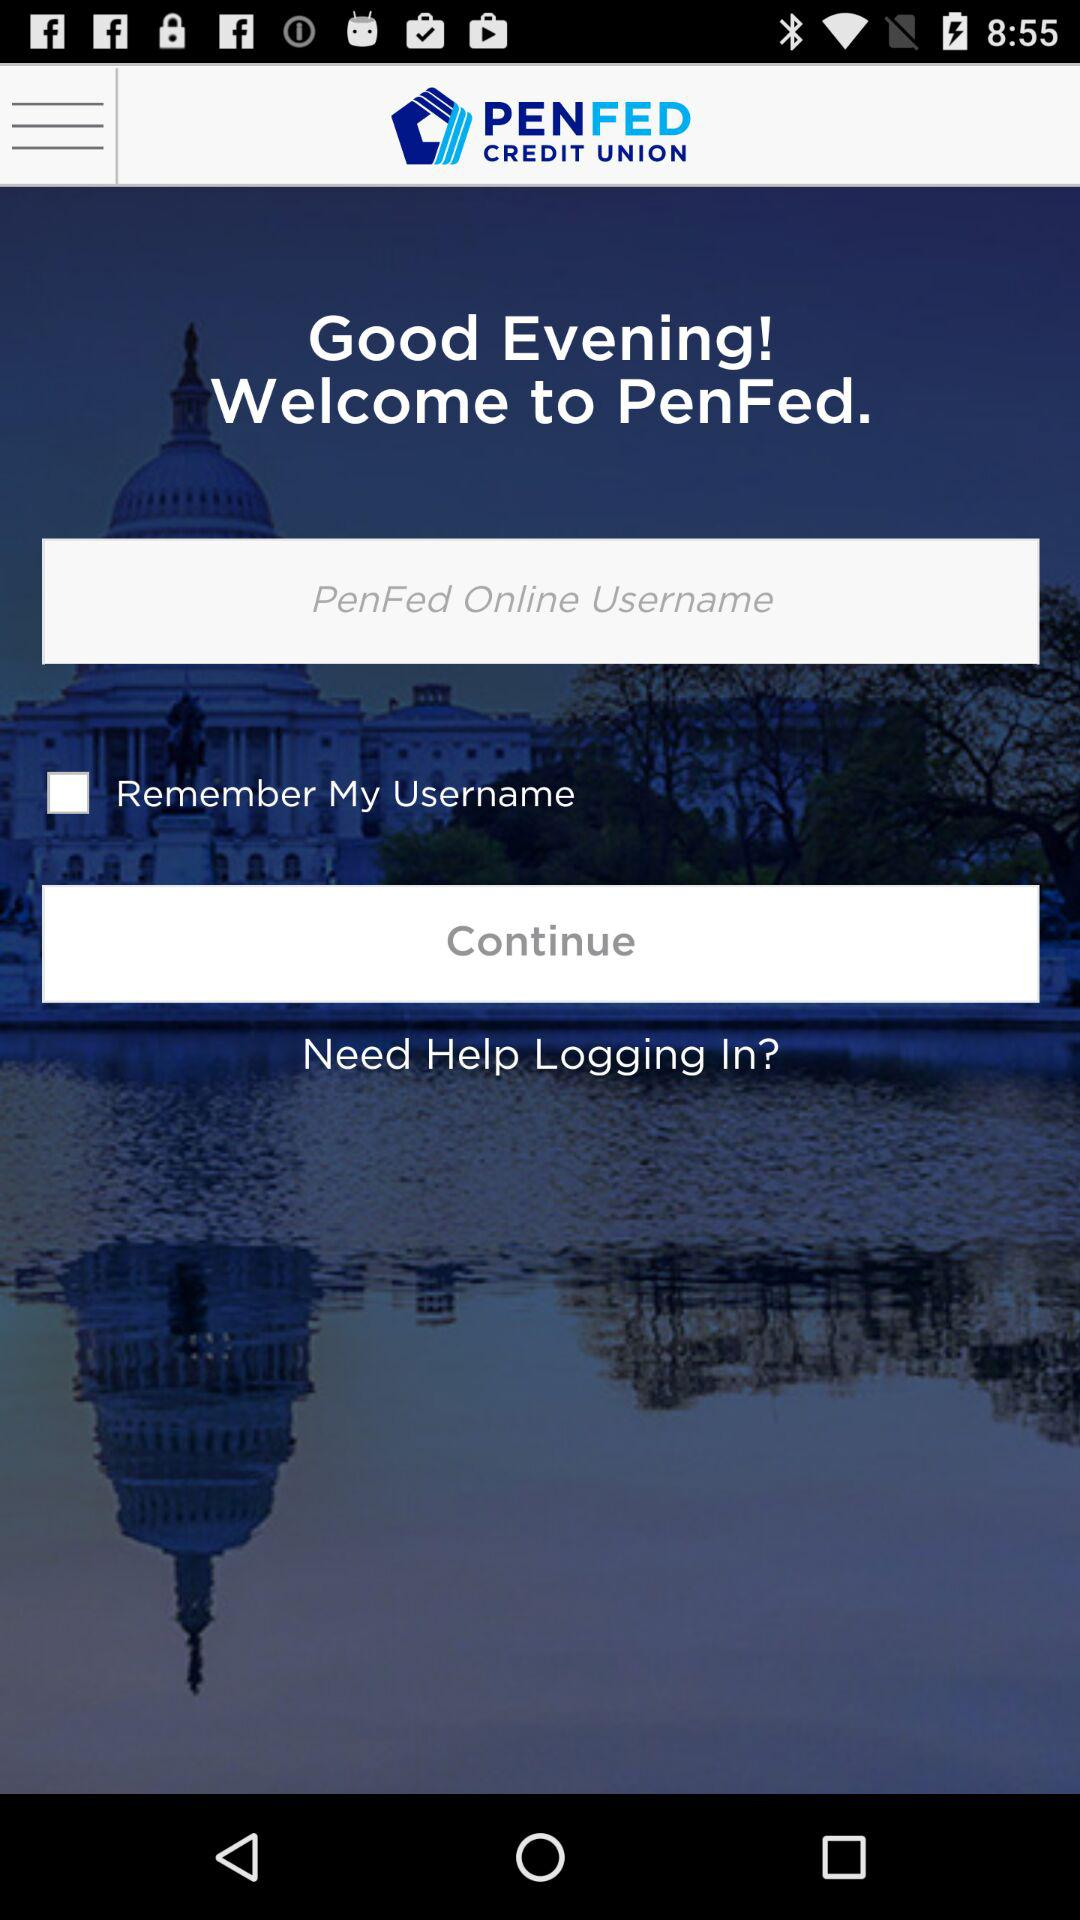Is "Remember My Username" checked or unchecked? "Remember My Username" is unchecked. 